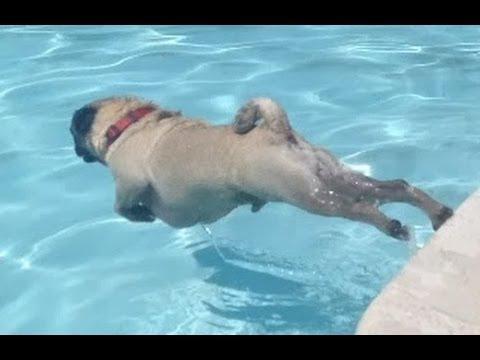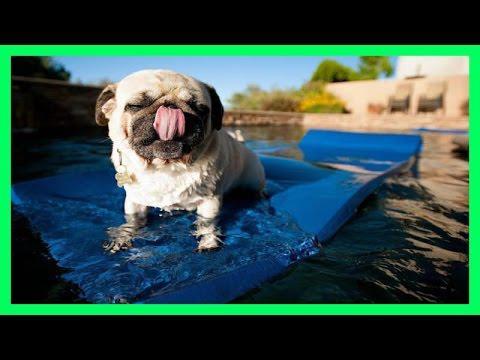The first image is the image on the left, the second image is the image on the right. For the images shown, is this caption "A dog is wearing a life vest." true? Answer yes or no. No. The first image is the image on the left, the second image is the image on the right. Examine the images to the left and right. Is the description "There is a pug wearing a life vest." accurate? Answer yes or no. No. 